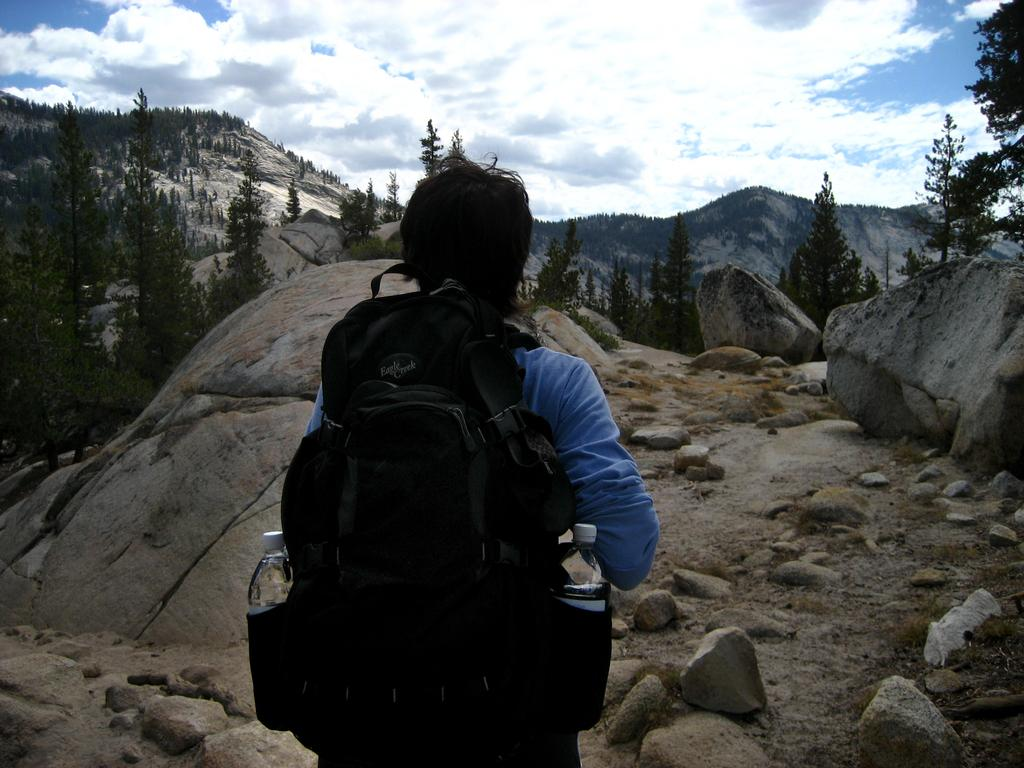Who is present in the image? There is a person in the image. What is the person carrying? The person is carrying a bag. What items are inside the bag? There are 2 bottles in the bag. What can be seen in the background of the image? There are rocks, trees, a mountain, and the sky visible in the background of the image. Where is the sugar field located in the image? There is no sugar field present in the image. What type of boats can be seen in the harbor in the image? There is no harbor present in the image. 